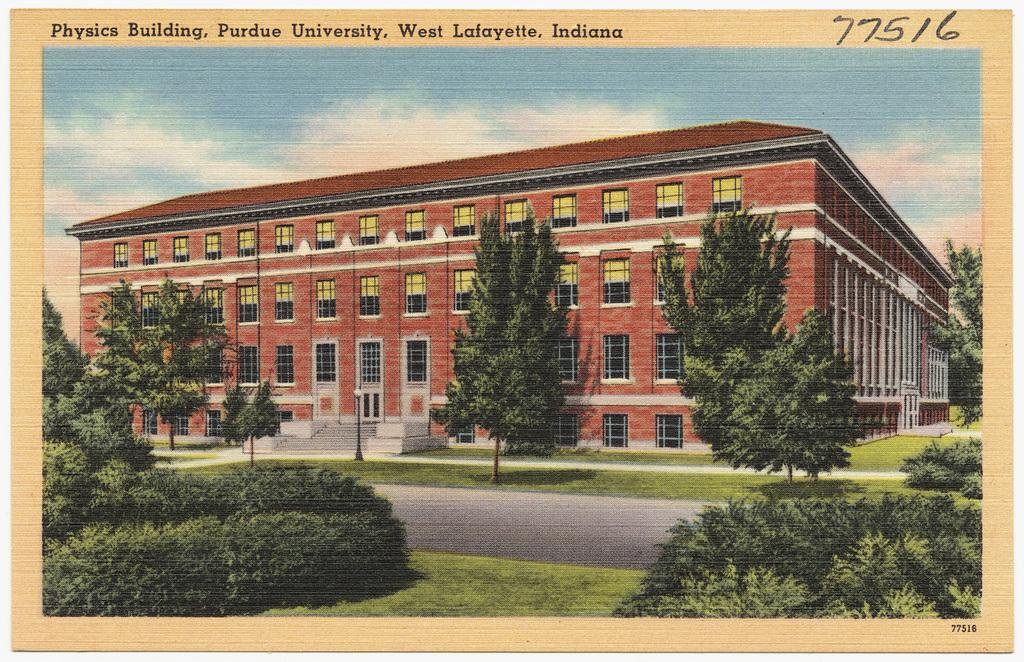What is the main structure visible in the image? There is a building in the image. What can be seen in front of the building? There are trees in front of the building. How is the ground depicted in the image? The ground is covered with greenery. Is there any text associated with the image? Yes, there is text written above the image. How many rakes are visible in the image? There are no rakes present in the image. What type of waste can be seen in the image? There is no waste visible in the image. 